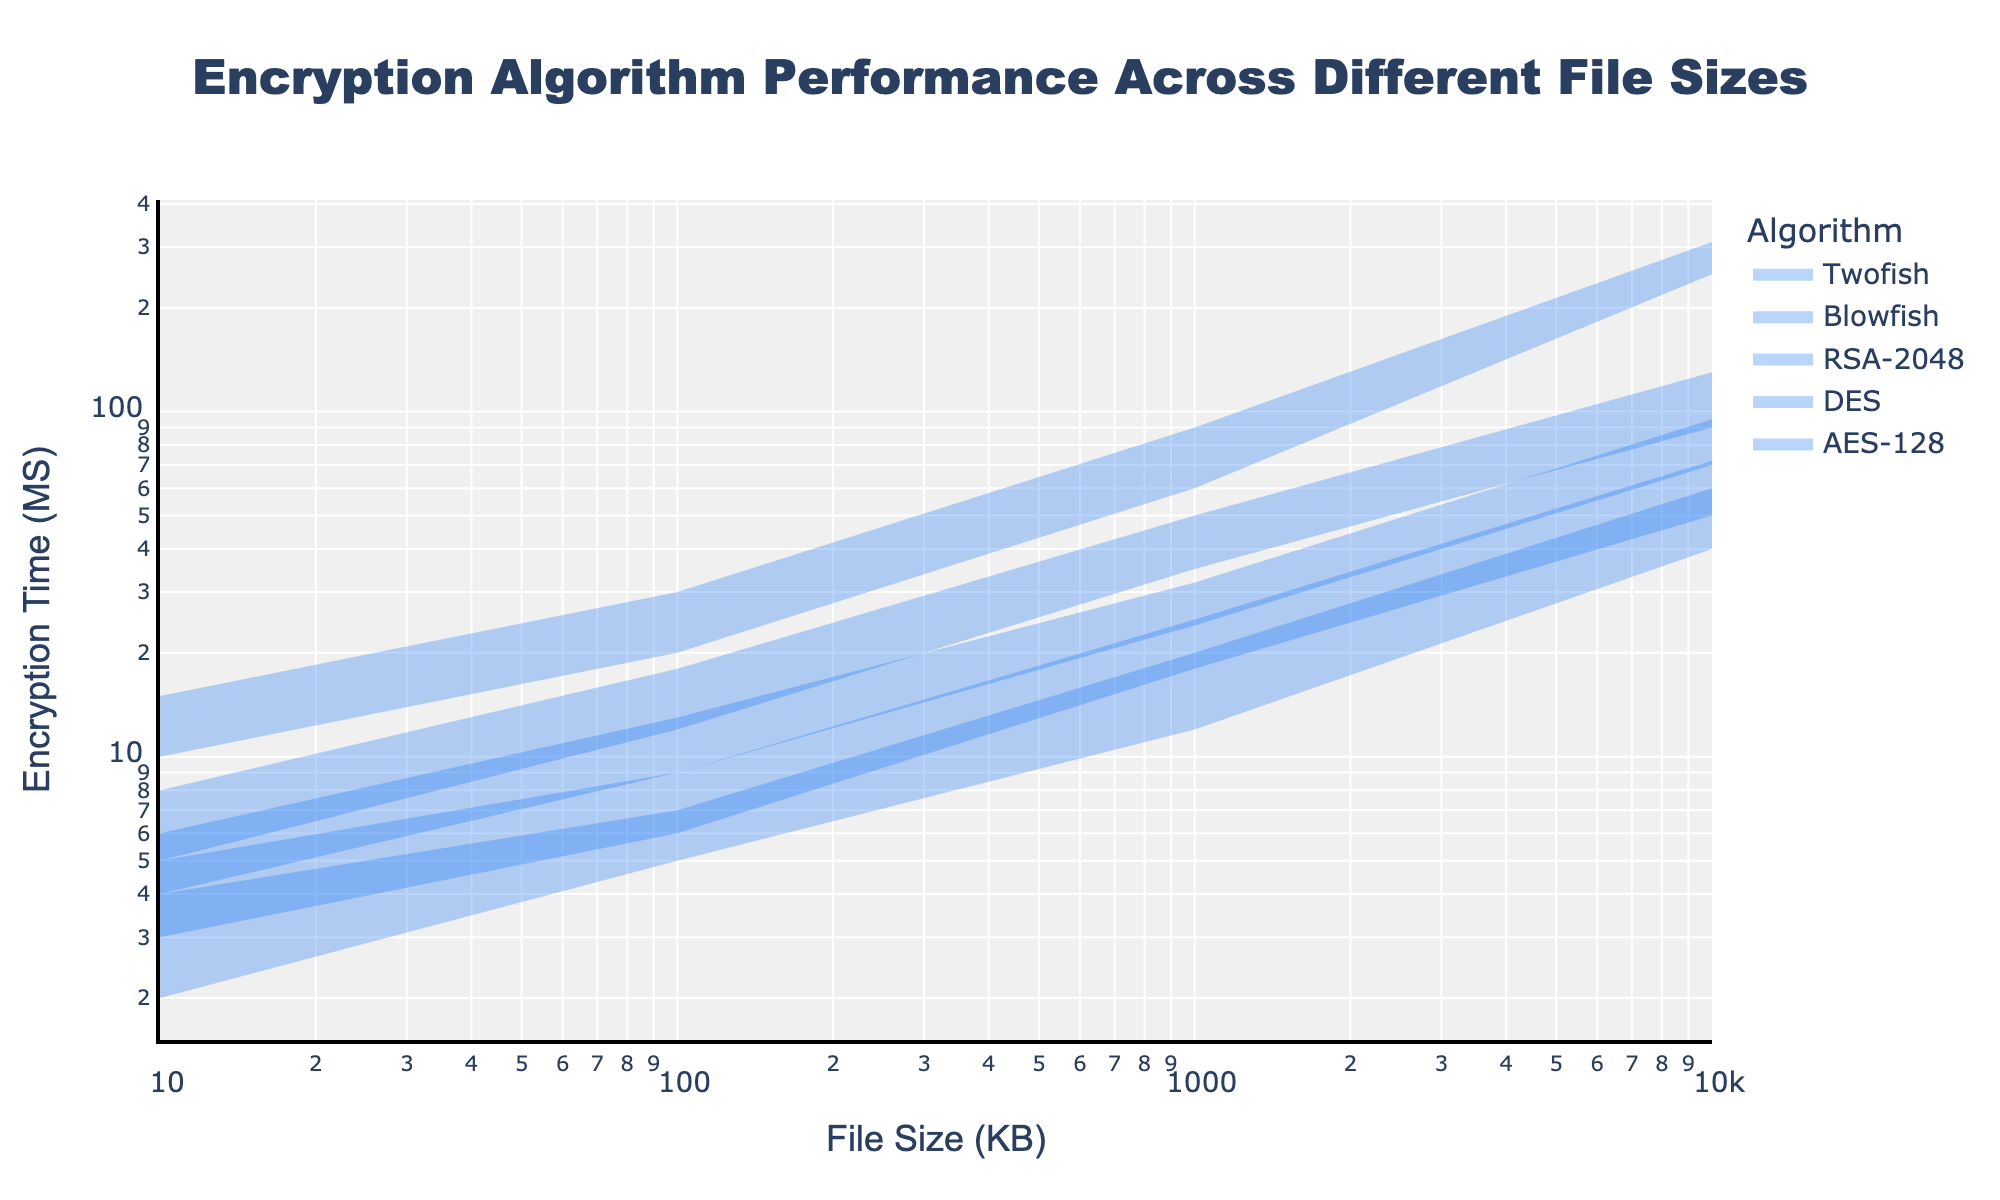What is the title of the figure? The title of the figure is prominently displayed at the top. It reads "Encryption Algorithm Performance Across Different File Sizes" in large, bold text.
Answer: Encryption Algorithm Performance Across Different File Sizes What is the range of encryption times for AES-128 when file size is 1000 KB? Locate the AES-128 range area on the plot for the file size 1000 KB. The minimum and maximum times can be directly read from the y-axis values where the band is filled.
Answer: 18 to 25 ms How does the performance of RSA-2048 compare to Blowfish for a 10 KB file size? Look at the 10 KB file size marker for both RSA-2048 and Blowfish area bands. RSA-2048 shows encryption times ranging from 10 to 15 ms, while Blowfish ranges from 2 to 4 ms.
Answer: RSA-2048 is slower Between which file sizes does DES show the largest variability in encryption time? Examine the vertical extent of the DES area bands for different file sizes. The largest range, indicating high variability, is from 90 to 130 ms, seen with the 10000 KB file size.
Answer: 10000 KB Which algorithm has the quickest minimum encryption time for the smallest file size? Identify the minimum encryption times for the smallest file size (10 KB). Compare the lowest value which is shown by Blowfish at 2 ms.
Answer: Blowfish If you have a file of 10000 KB, which algorithm will likely have the longest encryption time? At the 10000 KB mark, identify the algorithm with the highest maximum time band. RSA-2048 shows times ranging up to 310 ms.
Answer: RSA-2048 What is the minimum encryption time for Twofish at 100 KB? Locate the Twofish range band for the 100 KB file size and read the lower value on the y-axis.
Answer: 9 ms Which algorithm's performance is closest to linear based on the range area shape across file sizes? Examine the shape of the range bands for different algorithms. AES-128's band thickness remains relatively consistent, indicating more linear performance.
Answer: AES-128 Can you rank the algorithms by their maximum encryption time for a 1000 KB file size? Check the y-axis values for their maximum encryption times at 1000 KB for each algorithm. Rank them: RSA-2048 (90 ms), DES (50 ms), Twofish (32 ms), AES-128 (25 ms), Blowfish (20 ms).
Answer: RSA-2048, DES, Twofish, AES-128, Blowfish How does the variability of Blowfish's performance change with increasing file sizes? Observe the vertical spread of Blowfish's range band as file size increases. It starts narrow (2-4 ms at 10 KB) and remains relatively small (40-60 ms at 10000 KB).
Answer: Increases slightly but remains relatively narrow 